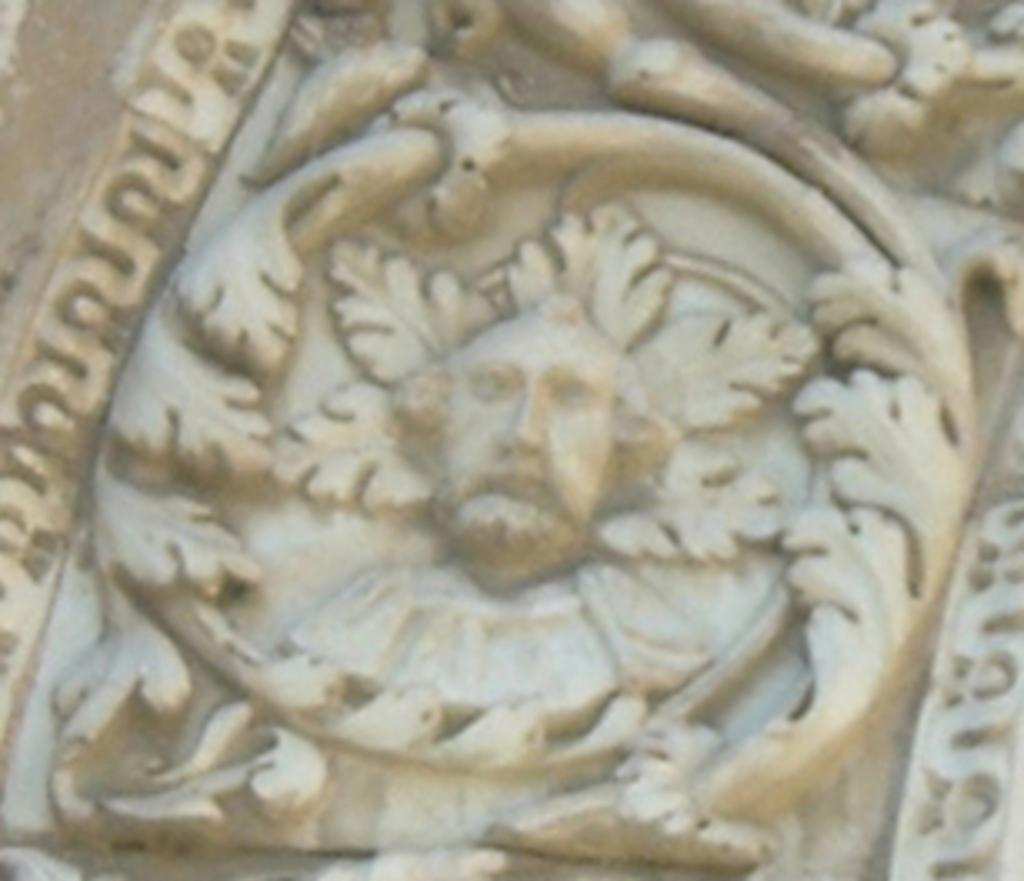What is the main subject of the image? There is a sculpture in the center of the image. How many cherries are on top of the sculpture in the image? There is no mention of cherries in the image, as the only fact provided is about the presence of a sculpture. 